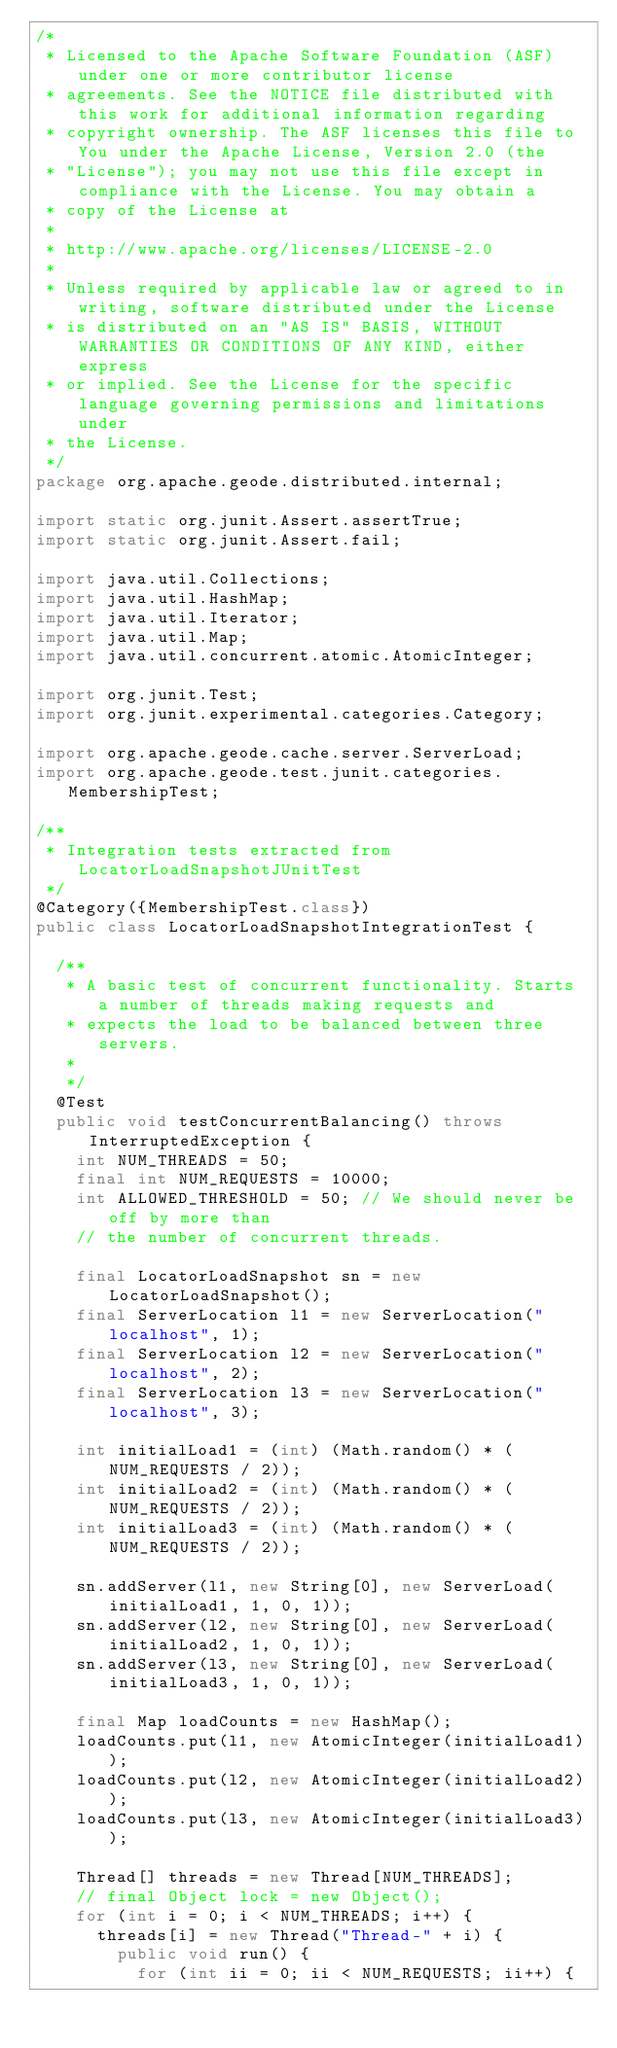<code> <loc_0><loc_0><loc_500><loc_500><_Java_>/*
 * Licensed to the Apache Software Foundation (ASF) under one or more contributor license
 * agreements. See the NOTICE file distributed with this work for additional information regarding
 * copyright ownership. The ASF licenses this file to You under the Apache License, Version 2.0 (the
 * "License"); you may not use this file except in compliance with the License. You may obtain a
 * copy of the License at
 *
 * http://www.apache.org/licenses/LICENSE-2.0
 *
 * Unless required by applicable law or agreed to in writing, software distributed under the License
 * is distributed on an "AS IS" BASIS, WITHOUT WARRANTIES OR CONDITIONS OF ANY KIND, either express
 * or implied. See the License for the specific language governing permissions and limitations under
 * the License.
 */
package org.apache.geode.distributed.internal;

import static org.junit.Assert.assertTrue;
import static org.junit.Assert.fail;

import java.util.Collections;
import java.util.HashMap;
import java.util.Iterator;
import java.util.Map;
import java.util.concurrent.atomic.AtomicInteger;

import org.junit.Test;
import org.junit.experimental.categories.Category;

import org.apache.geode.cache.server.ServerLoad;
import org.apache.geode.test.junit.categories.MembershipTest;

/**
 * Integration tests extracted from LocatorLoadSnapshotJUnitTest
 */
@Category({MembershipTest.class})
public class LocatorLoadSnapshotIntegrationTest {

  /**
   * A basic test of concurrent functionality. Starts a number of threads making requests and
   * expects the load to be balanced between three servers.
   *
   */
  @Test
  public void testConcurrentBalancing() throws InterruptedException {
    int NUM_THREADS = 50;
    final int NUM_REQUESTS = 10000;
    int ALLOWED_THRESHOLD = 50; // We should never be off by more than
    // the number of concurrent threads.

    final LocatorLoadSnapshot sn = new LocatorLoadSnapshot();
    final ServerLocation l1 = new ServerLocation("localhost", 1);
    final ServerLocation l2 = new ServerLocation("localhost", 2);
    final ServerLocation l3 = new ServerLocation("localhost", 3);

    int initialLoad1 = (int) (Math.random() * (NUM_REQUESTS / 2));
    int initialLoad2 = (int) (Math.random() * (NUM_REQUESTS / 2));
    int initialLoad3 = (int) (Math.random() * (NUM_REQUESTS / 2));

    sn.addServer(l1, new String[0], new ServerLoad(initialLoad1, 1, 0, 1));
    sn.addServer(l2, new String[0], new ServerLoad(initialLoad2, 1, 0, 1));
    sn.addServer(l3, new String[0], new ServerLoad(initialLoad3, 1, 0, 1));

    final Map loadCounts = new HashMap();
    loadCounts.put(l1, new AtomicInteger(initialLoad1));
    loadCounts.put(l2, new AtomicInteger(initialLoad2));
    loadCounts.put(l3, new AtomicInteger(initialLoad3));

    Thread[] threads = new Thread[NUM_THREADS];
    // final Object lock = new Object();
    for (int i = 0; i < NUM_THREADS; i++) {
      threads[i] = new Thread("Thread-" + i) {
        public void run() {
          for (int ii = 0; ii < NUM_REQUESTS; ii++) {</code> 